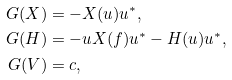Convert formula to latex. <formula><loc_0><loc_0><loc_500><loc_500>G ( X ) & = - X ( u ) u ^ { * } , \\ G ( H ) & = - u X ( f ) u ^ { * } - H ( u ) u ^ { * } , \\ G ( V ) & = c ,</formula> 